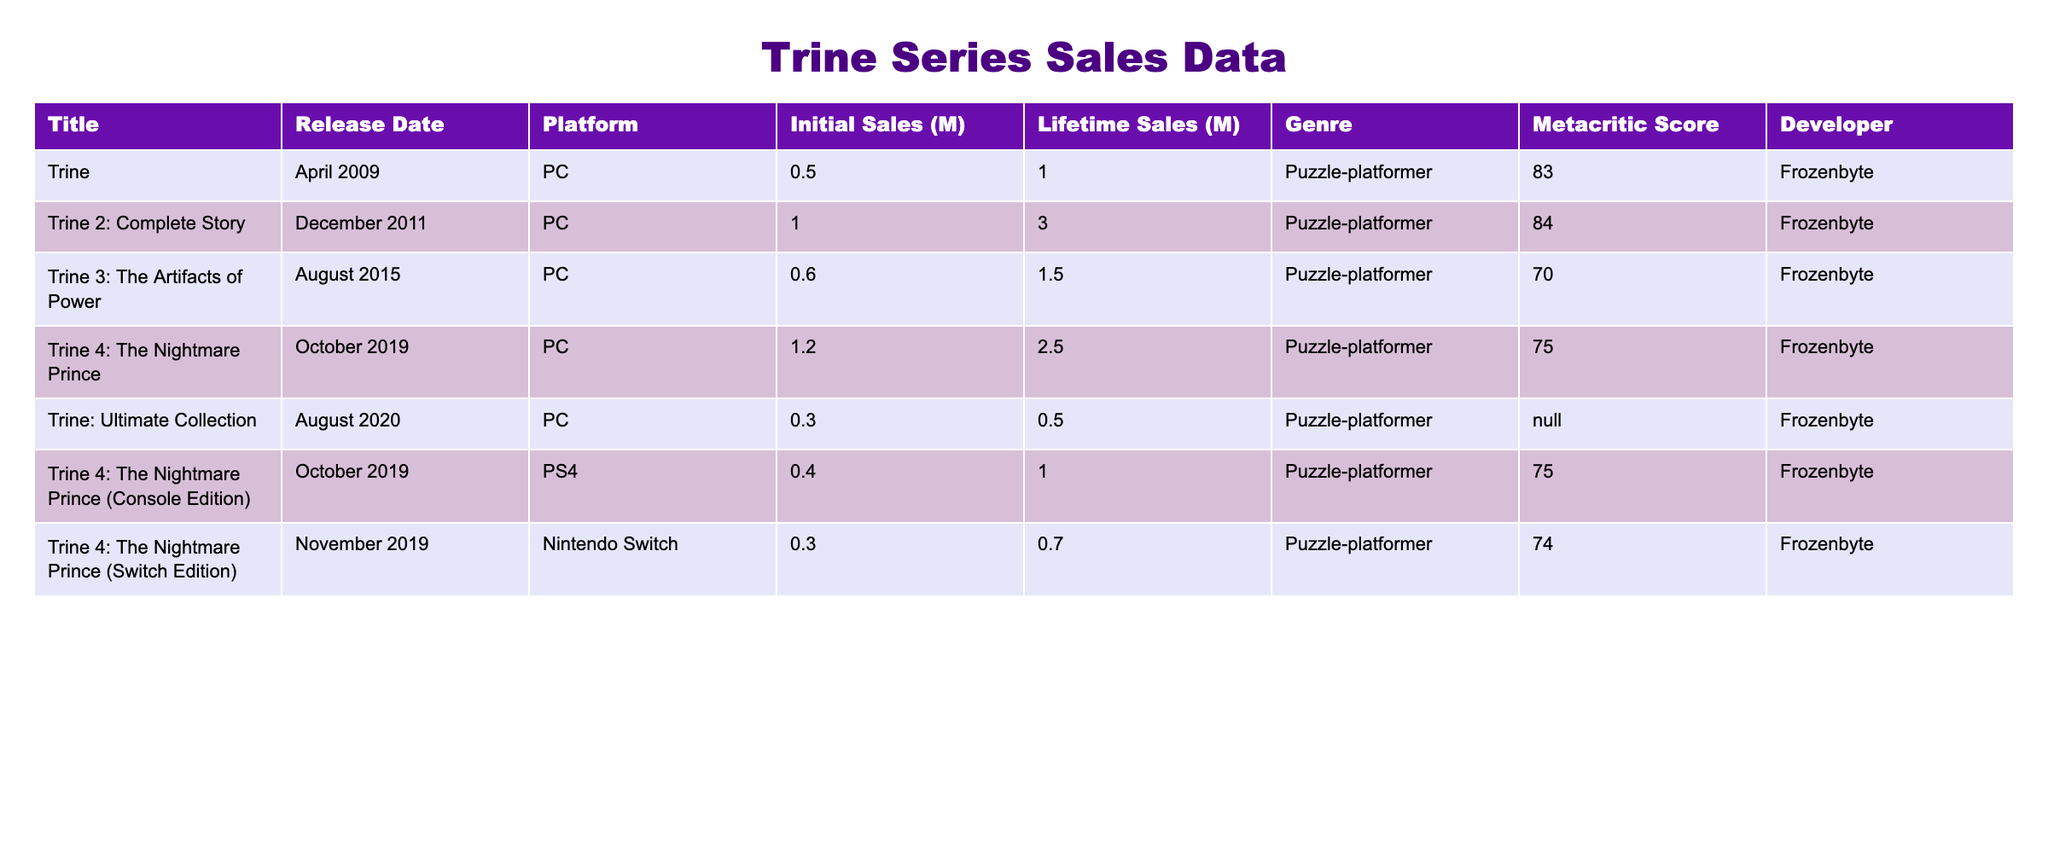What is the Metacritic score for "Trine 2: Complete Story"? The table lists the Metacritic score for "Trine 2: Complete Story" under the respective column, which shows a score of 84.
Answer: 84 Which game has the highest initial sales? By looking at the "Initial Sales (M)" column, "Trine 4: The Nightmare Prince" has the highest value at 1.2 million units.
Answer: 1.2 million What is the lifetime sales for "Trine: Ultimate Collection"? The table shows that the lifetime sales for "Trine: Ultimate Collection" is recorded as 0.5 million units.
Answer: 0.5 million True or False: "Trine 3: The Artifacts of Power" has a higher Metacritic score than "Trine 4: The Nightmare Prince". The Metacritic score for "Trine 3" is 70, and for "Trine 4" it is 75; therefore, "Trine 3" has a lower score than "Trine 4".
Answer: False What is the total lifetime sales of all Trine games listed in the table? Adding the lifetime sales: 1.0 + 3.0 + 1.5 + 2.5 + 0.5 + 1.0 + 0.7 = 10.2 million units.
Answer: 10.2 million Which console version of "Trine 4: The Nightmare Prince" had the lowest initial sales? Comparing the initial sales of different versions: PC (1.2), PS4 (0.4), Switch (0.3), the Switch edition has the lowest initial sales at 0.3 million.
Answer: Switch edition What percentage of the initial sales of "Trine" is represented by the initial sales of "Trine 2: Complete Story"? The initial sales of "Trine" are 0.5 million and for "Trine 2" are 1.0 million, so (0.5 / 1.0) * 100 = 50%.
Answer: 50% Which game had the lowest lifetime sales overall? By checking the "Lifetime Sales (M)" column, "Trine: Ultimate Collection" has the lowest lifetime sales recorded at 0.5 million units.
Answer: Trine: Ultimate Collection What is the average Metacritic score of all the games in the table? The scores are 83, 84, 70, 75, N/A, 75, 74; excluding N/A gives us (83 + 84 + 70 + 75 + 75 + 74) / 6 = 76.5.
Answer: 76.5 If we exclude the years as part of the game titles, which two titles have the highest lifetime sales? Analyzing lifetime sales, "Trine 2: Complete Story" (3.0) and "Trine 4: The Nightmare Prince" (2.5) have the highest values.
Answer: Trine 2: Complete Story, Trine 4: The Nightmare Prince 